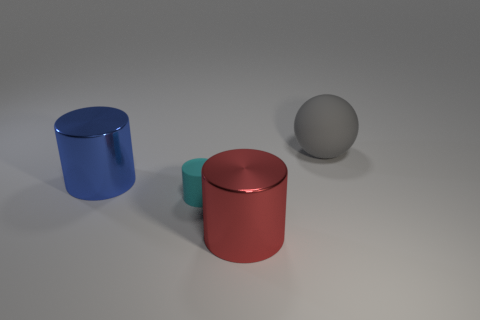Is there anything else that is the same size as the cyan matte thing?
Your response must be concise. No. There is a metal cylinder behind the object in front of the matte thing left of the big gray matte sphere; how big is it?
Offer a terse response. Large. Are there the same number of tiny cyan cylinders that are on the right side of the red cylinder and gray rubber spheres in front of the gray matte sphere?
Provide a short and direct response. Yes. What is the size of the red cylinder that is made of the same material as the big blue object?
Ensure brevity in your answer.  Large. The rubber cylinder is what color?
Ensure brevity in your answer.  Cyan. How many metallic things are the same color as the small rubber cylinder?
Provide a short and direct response. 0. There is a gray ball that is the same size as the blue object; what is it made of?
Provide a succinct answer. Rubber. Are there any cyan cylinders that are in front of the rubber object in front of the large gray ball?
Offer a very short reply. No. What number of other things are there of the same color as the sphere?
Offer a terse response. 0. The cyan matte thing has what size?
Offer a terse response. Small. 